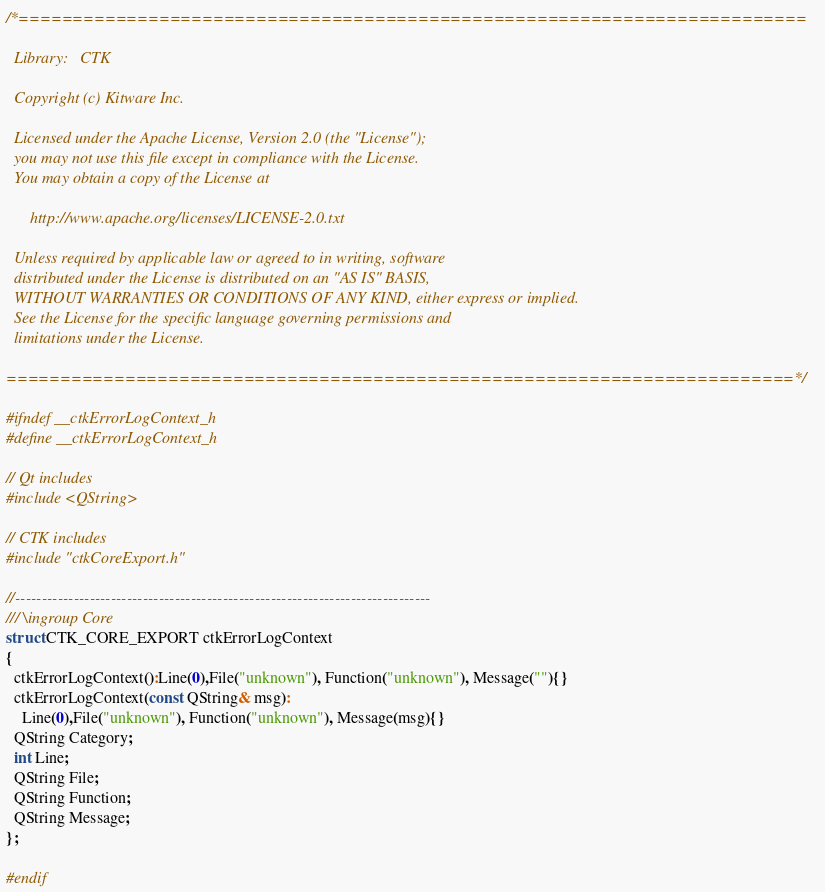Convert code to text. <code><loc_0><loc_0><loc_500><loc_500><_C_>/*=========================================================================

  Library:   CTK

  Copyright (c) Kitware Inc.

  Licensed under the Apache License, Version 2.0 (the "License");
  you may not use this file except in compliance with the License.
  You may obtain a copy of the License at

      http://www.apache.org/licenses/LICENSE-2.0.txt

  Unless required by applicable law or agreed to in writing, software
  distributed under the License is distributed on an "AS IS" BASIS,
  WITHOUT WARRANTIES OR CONDITIONS OF ANY KIND, either express or implied.
  See the License for the specific language governing permissions and
  limitations under the License.

=========================================================================*/

#ifndef __ctkErrorLogContext_h
#define __ctkErrorLogContext_h

// Qt includes
#include <QString>

// CTK includes
#include "ctkCoreExport.h"

//------------------------------------------------------------------------------
/// \ingroup Core
struct CTK_CORE_EXPORT ctkErrorLogContext
{
  ctkErrorLogContext():Line(0),File("unknown"), Function("unknown"), Message(""){}
  ctkErrorLogContext(const QString& msg):
    Line(0),File("unknown"), Function("unknown"), Message(msg){}
  QString Category;
  int Line;
  QString File;
  QString Function;
  QString Message;
};

#endif
</code> 